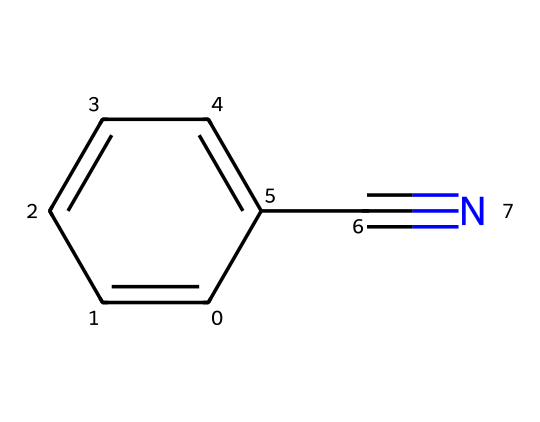What is the name of this chemical? The SMILES representation c1ccccc1C#N indicates that the compound has a benzene ring (represented by "c1ccccc1") with a nitrile functional group (C#N). Combining these gives the name benzonitrile.
Answer: benzonitrile How many carbon atoms are there in benzonitrile? The structure shows a benzene ring with six carbon atoms and one additional carbon from the nitrile group, resulting in a total of seven carbon atoms.
Answer: seven What is the type of functional group present in benzonitrile? The C#N part of the SMILES indicates the presence of a nitrile functional group, which is characteristic of compounds that contain a carbon triple-bonded to a nitrogen.
Answer: nitrile How many hydrogen atoms does benzonitrile contain? The benzene ring has five hydrogen atoms (as one hydrogen is replaced by the nitrile group), resulting in a total of five hydrogen atoms in benzonitrile.
Answer: five What type of compound is benzonitrile classified as? Benzonitrile has a nitrile functional group, which classifies it as an organic compound in the nitrile class. Combined with its aromatic ring, it's often classified as an aromatic nitrile.
Answer: aromatic nitrile Is benzonitrile polar or non-polar? The presence of a nitrile group, which has a polar triple bond with nitrogen, contributes to the polarity of the molecule, but the overall structure, being aromatic, leans towards non-polar characteristics. Hence, it's mainly considered non-polar.
Answer: non-polar 